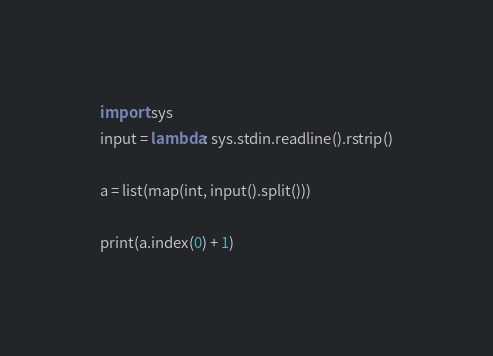Convert code to text. <code><loc_0><loc_0><loc_500><loc_500><_Python_>import sys
input = lambda: sys.stdin.readline().rstrip()

a = list(map(int, input().split()))

print(a.index(0) + 1)</code> 